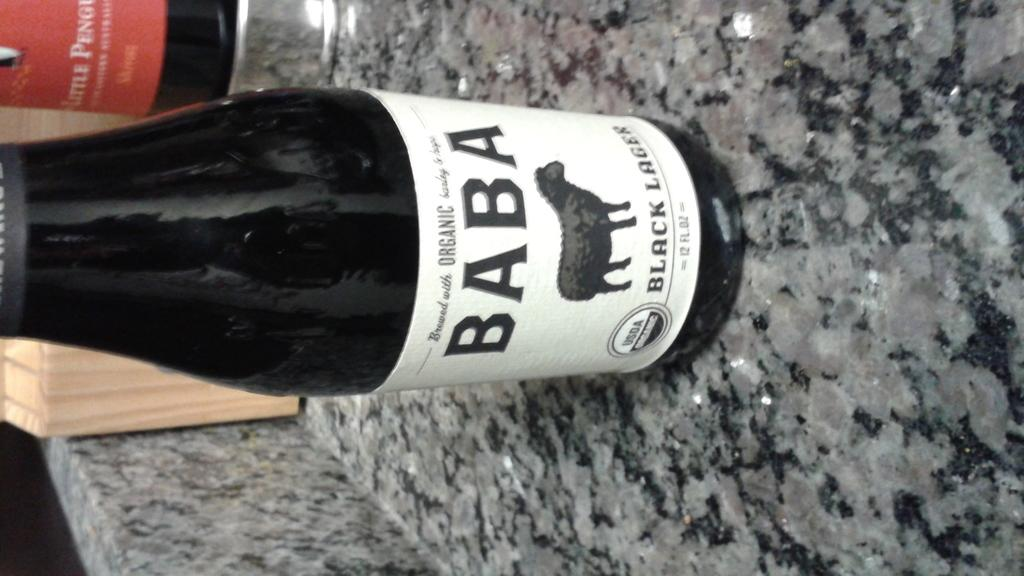<image>
Create a compact narrative representing the image presented. A bottle of black lager labeled "Baba" sits on a countertop 